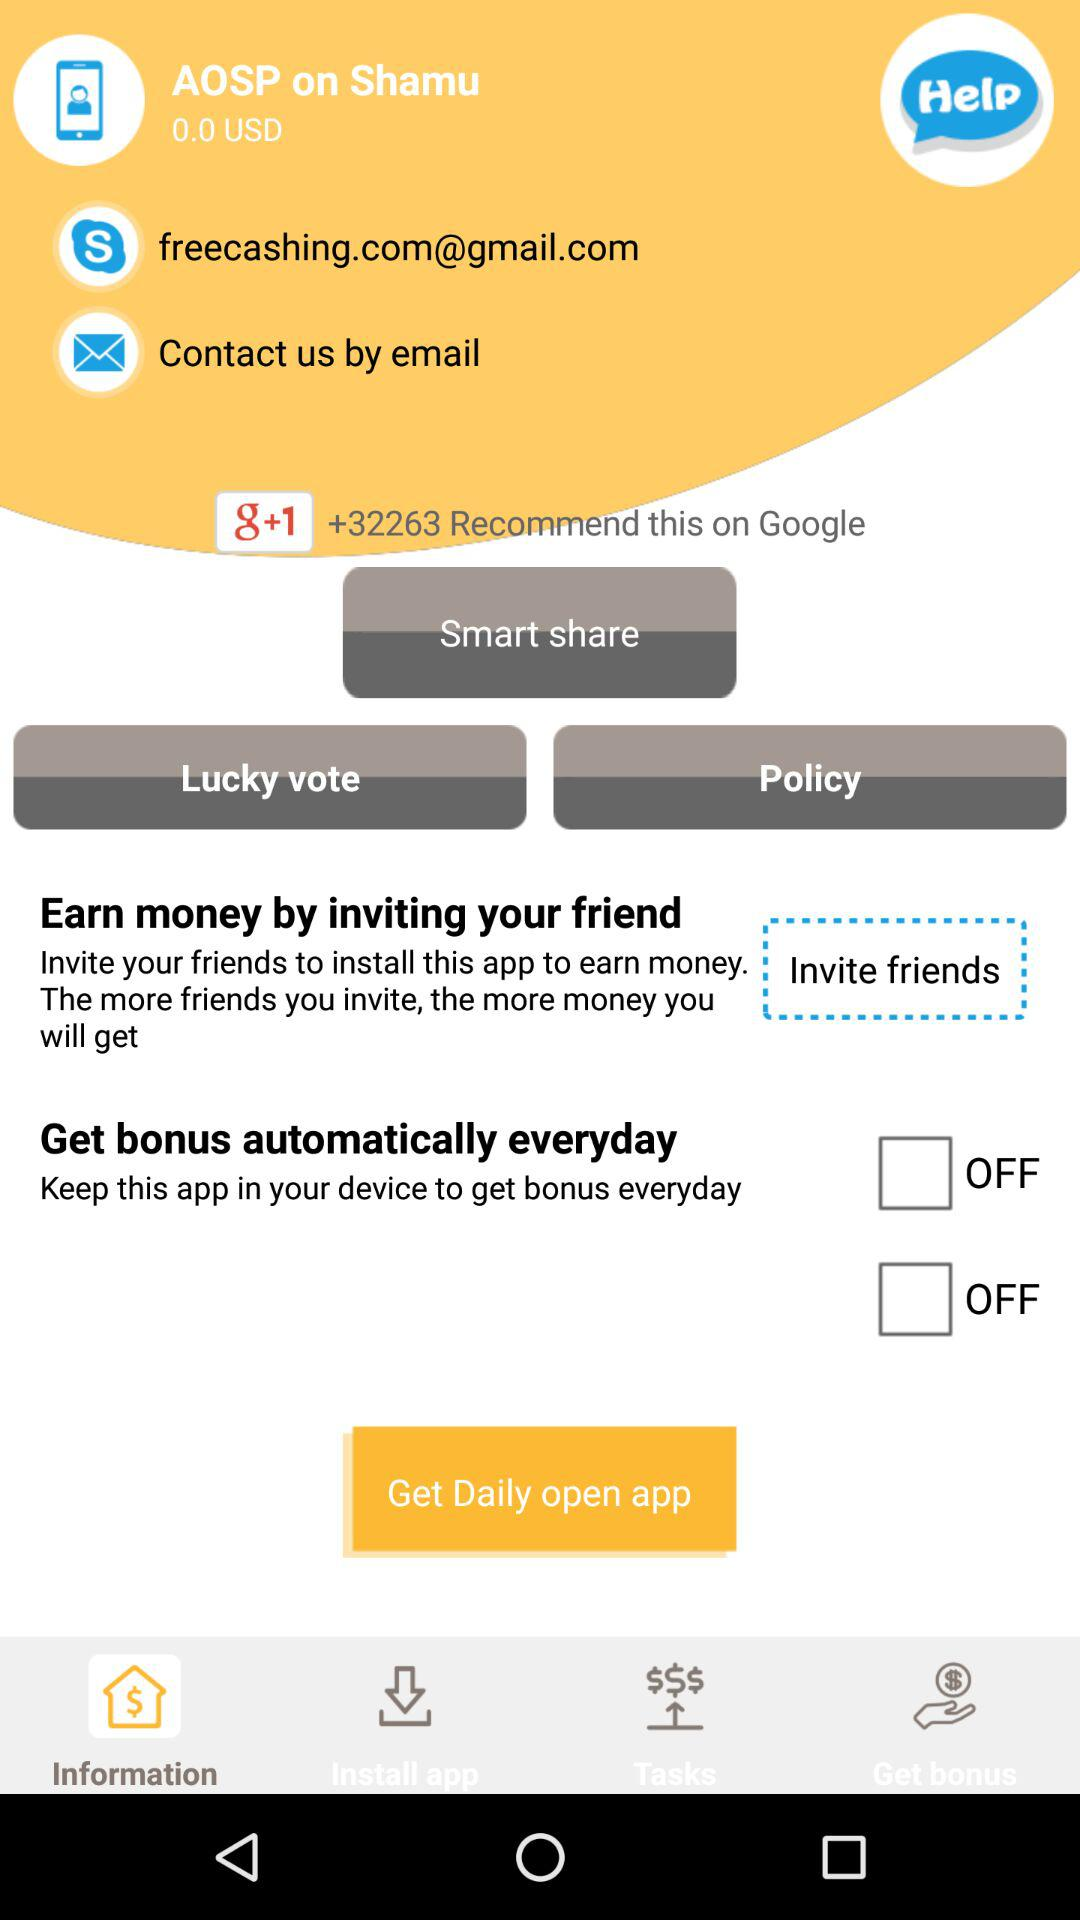How to invite friends?
When the provided information is insufficient, respond with <no answer>. <no answer> 